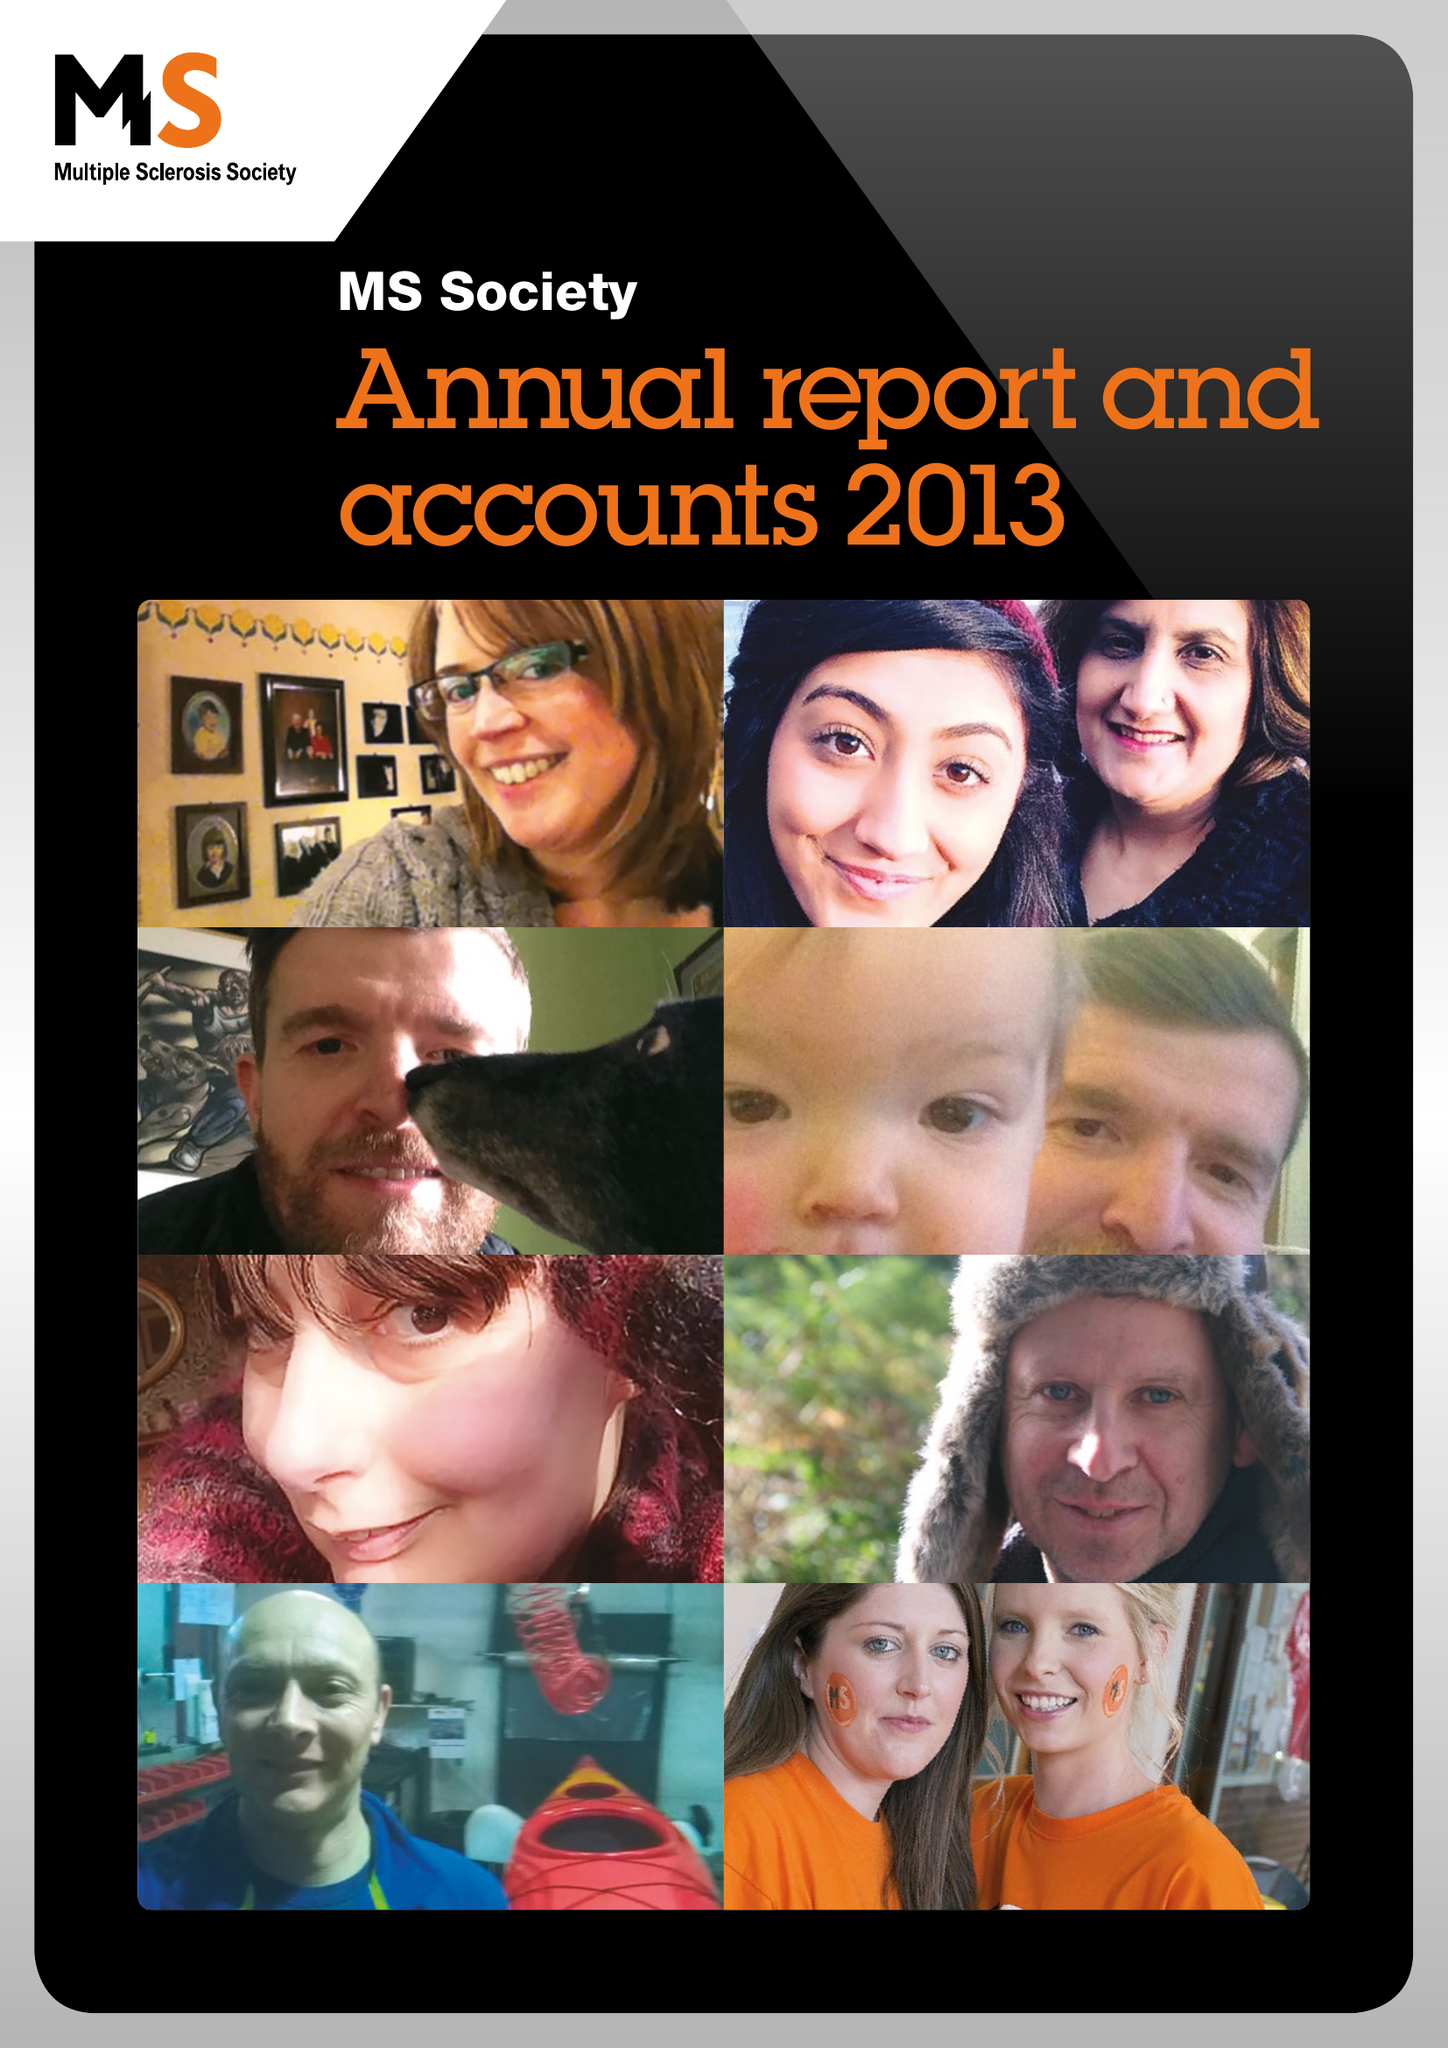What is the value for the report_date?
Answer the question using a single word or phrase. 2013-12-31 